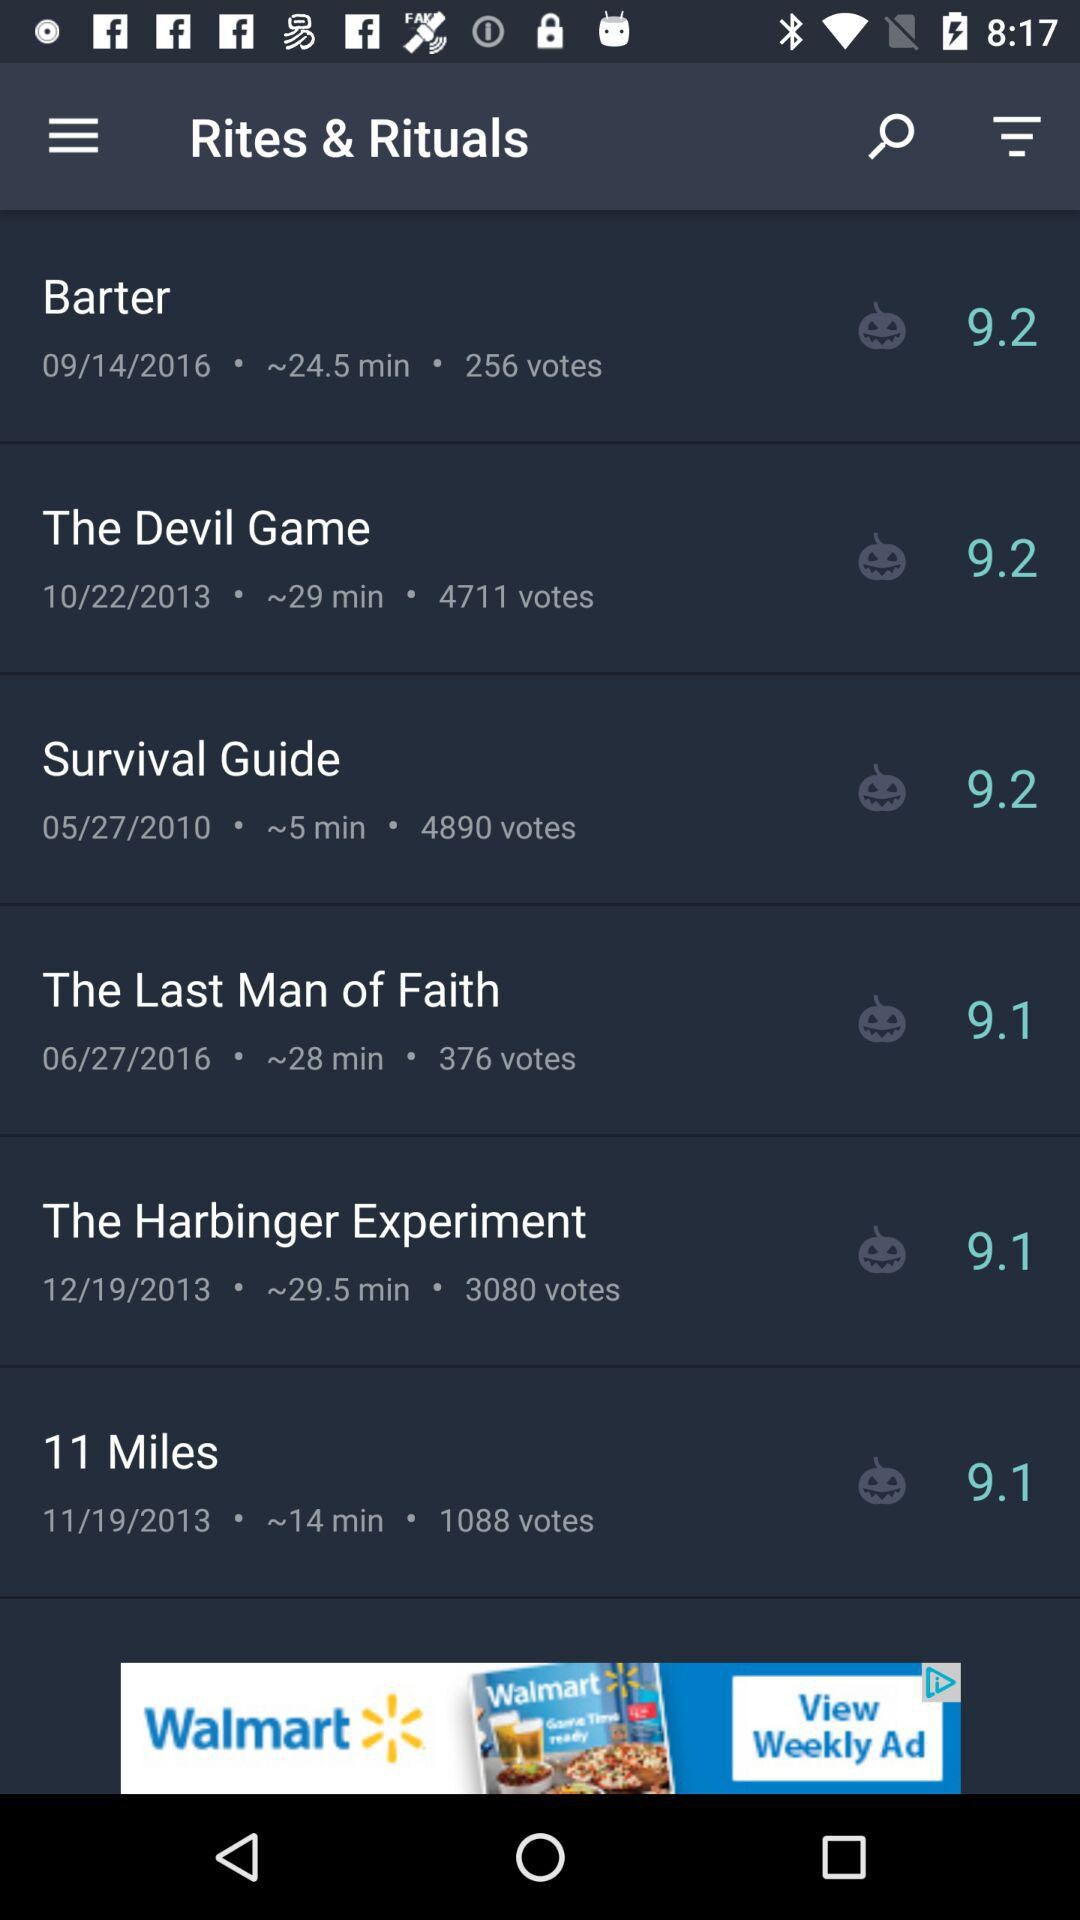How long does the survival guide last? The survival guide is ~5 minutes long. 